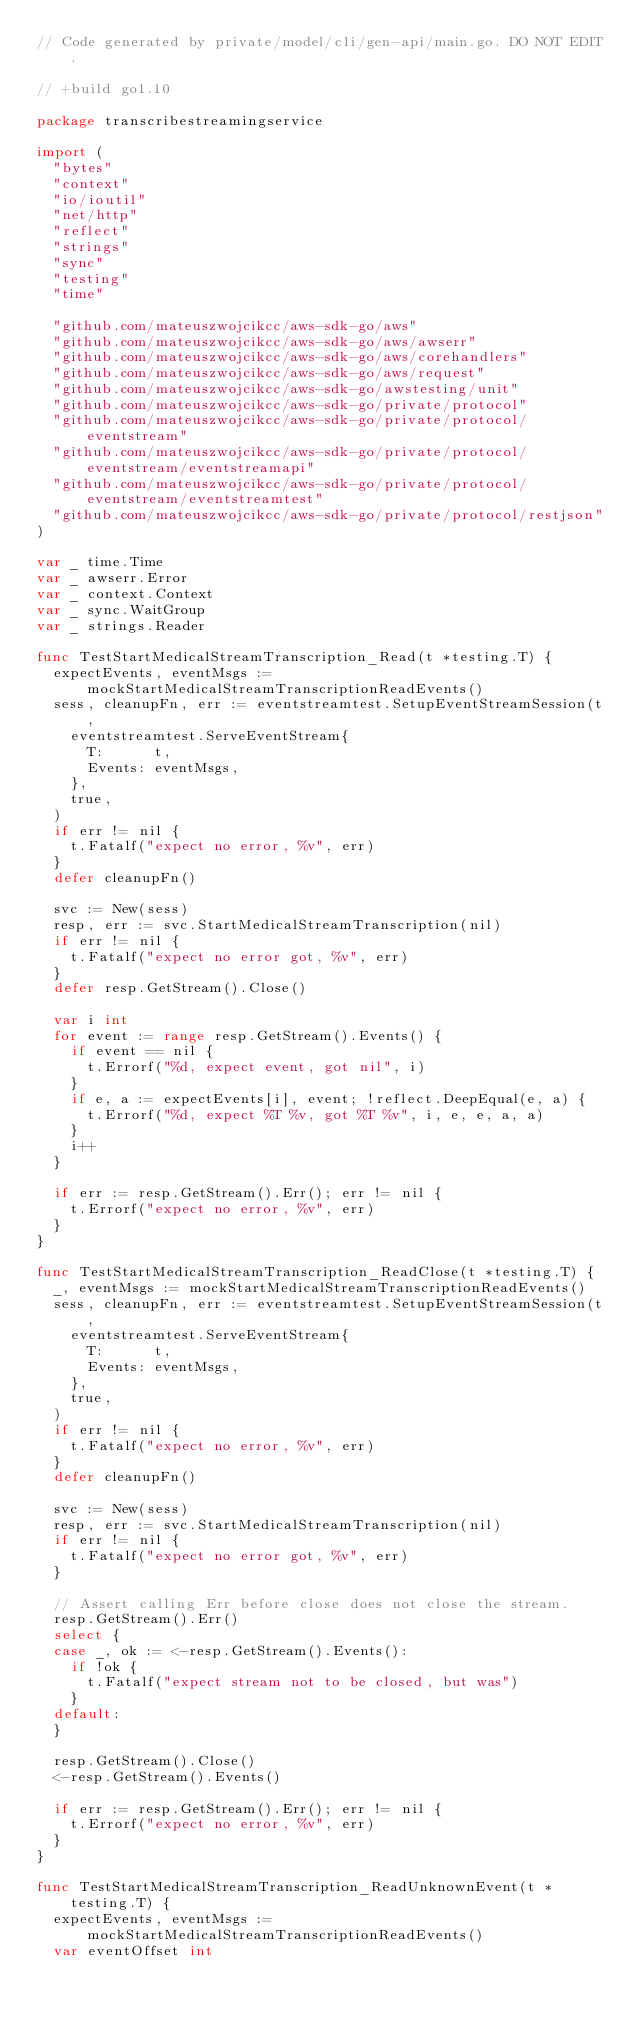Convert code to text. <code><loc_0><loc_0><loc_500><loc_500><_Go_>// Code generated by private/model/cli/gen-api/main.go. DO NOT EDIT.

// +build go1.10

package transcribestreamingservice

import (
	"bytes"
	"context"
	"io/ioutil"
	"net/http"
	"reflect"
	"strings"
	"sync"
	"testing"
	"time"

	"github.com/mateuszwojcikcc/aws-sdk-go/aws"
	"github.com/mateuszwojcikcc/aws-sdk-go/aws/awserr"
	"github.com/mateuszwojcikcc/aws-sdk-go/aws/corehandlers"
	"github.com/mateuszwojcikcc/aws-sdk-go/aws/request"
	"github.com/mateuszwojcikcc/aws-sdk-go/awstesting/unit"
	"github.com/mateuszwojcikcc/aws-sdk-go/private/protocol"
	"github.com/mateuszwojcikcc/aws-sdk-go/private/protocol/eventstream"
	"github.com/mateuszwojcikcc/aws-sdk-go/private/protocol/eventstream/eventstreamapi"
	"github.com/mateuszwojcikcc/aws-sdk-go/private/protocol/eventstream/eventstreamtest"
	"github.com/mateuszwojcikcc/aws-sdk-go/private/protocol/restjson"
)

var _ time.Time
var _ awserr.Error
var _ context.Context
var _ sync.WaitGroup
var _ strings.Reader

func TestStartMedicalStreamTranscription_Read(t *testing.T) {
	expectEvents, eventMsgs := mockStartMedicalStreamTranscriptionReadEvents()
	sess, cleanupFn, err := eventstreamtest.SetupEventStreamSession(t,
		eventstreamtest.ServeEventStream{
			T:      t,
			Events: eventMsgs,
		},
		true,
	)
	if err != nil {
		t.Fatalf("expect no error, %v", err)
	}
	defer cleanupFn()

	svc := New(sess)
	resp, err := svc.StartMedicalStreamTranscription(nil)
	if err != nil {
		t.Fatalf("expect no error got, %v", err)
	}
	defer resp.GetStream().Close()

	var i int
	for event := range resp.GetStream().Events() {
		if event == nil {
			t.Errorf("%d, expect event, got nil", i)
		}
		if e, a := expectEvents[i], event; !reflect.DeepEqual(e, a) {
			t.Errorf("%d, expect %T %v, got %T %v", i, e, e, a, a)
		}
		i++
	}

	if err := resp.GetStream().Err(); err != nil {
		t.Errorf("expect no error, %v", err)
	}
}

func TestStartMedicalStreamTranscription_ReadClose(t *testing.T) {
	_, eventMsgs := mockStartMedicalStreamTranscriptionReadEvents()
	sess, cleanupFn, err := eventstreamtest.SetupEventStreamSession(t,
		eventstreamtest.ServeEventStream{
			T:      t,
			Events: eventMsgs,
		},
		true,
	)
	if err != nil {
		t.Fatalf("expect no error, %v", err)
	}
	defer cleanupFn()

	svc := New(sess)
	resp, err := svc.StartMedicalStreamTranscription(nil)
	if err != nil {
		t.Fatalf("expect no error got, %v", err)
	}

	// Assert calling Err before close does not close the stream.
	resp.GetStream().Err()
	select {
	case _, ok := <-resp.GetStream().Events():
		if !ok {
			t.Fatalf("expect stream not to be closed, but was")
		}
	default:
	}

	resp.GetStream().Close()
	<-resp.GetStream().Events()

	if err := resp.GetStream().Err(); err != nil {
		t.Errorf("expect no error, %v", err)
	}
}

func TestStartMedicalStreamTranscription_ReadUnknownEvent(t *testing.T) {
	expectEvents, eventMsgs := mockStartMedicalStreamTranscriptionReadEvents()
	var eventOffset int
</code> 